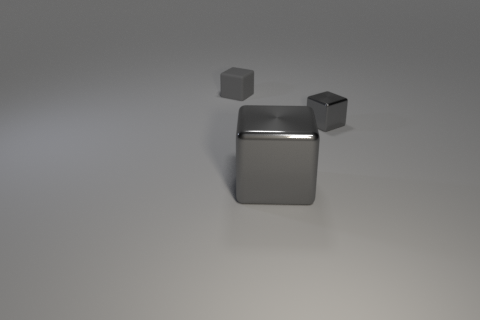What size is the other gray metal object that is the same shape as the small metallic object?
Give a very brief answer. Large. What number of other rubber things are the same size as the matte thing?
Provide a short and direct response. 0. What is the material of the large gray thing?
Make the answer very short. Metal. There is a large gray block; are there any gray shiny objects behind it?
Offer a terse response. Yes. What number of tiny rubber blocks have the same color as the large metallic cube?
Provide a short and direct response. 1. Is the number of large gray blocks that are behind the gray matte cube less than the number of gray blocks that are behind the big gray object?
Give a very brief answer. Yes. What size is the gray metal object that is in front of the small gray metallic object?
Provide a succinct answer. Large. There is another metal block that is the same color as the small metal block; what is its size?
Ensure brevity in your answer.  Large. Are there any blue cylinders made of the same material as the big gray cube?
Provide a short and direct response. No. There is a metal thing that is the same size as the matte thing; what is its color?
Your response must be concise. Gray. 